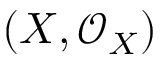Convert formula to latex. <formula><loc_0><loc_0><loc_500><loc_500>( X , { \mathcal { O } } _ { X } )</formula> 